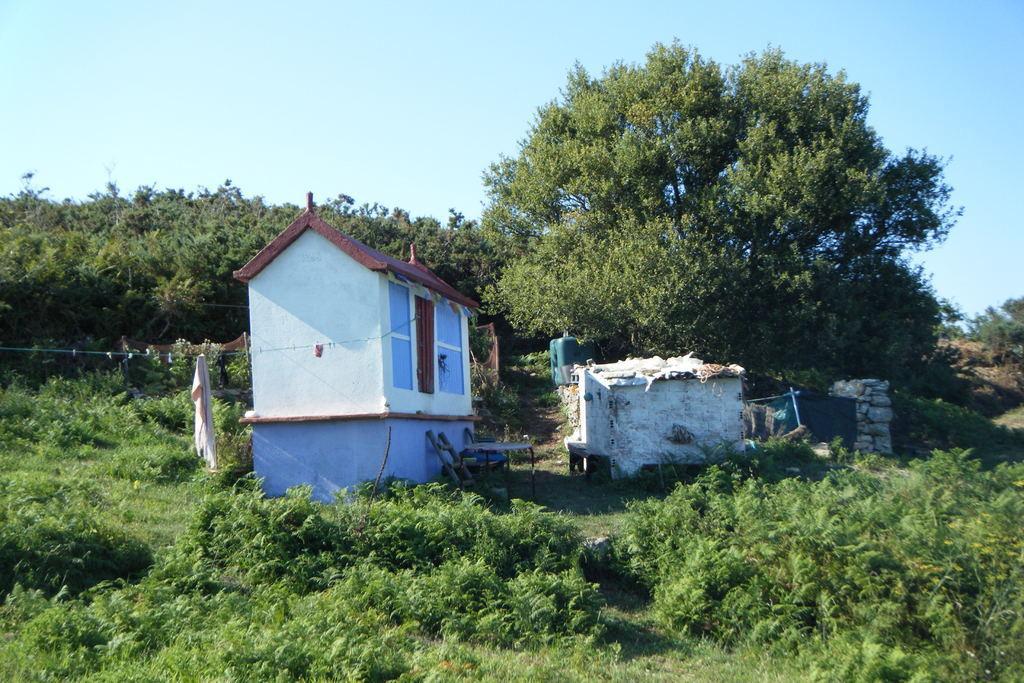Describe this image in one or two sentences. In the foreground I can see plants, grass, houses and trees. At the top I can see the blue sky. This image is taken may be in a farm. 